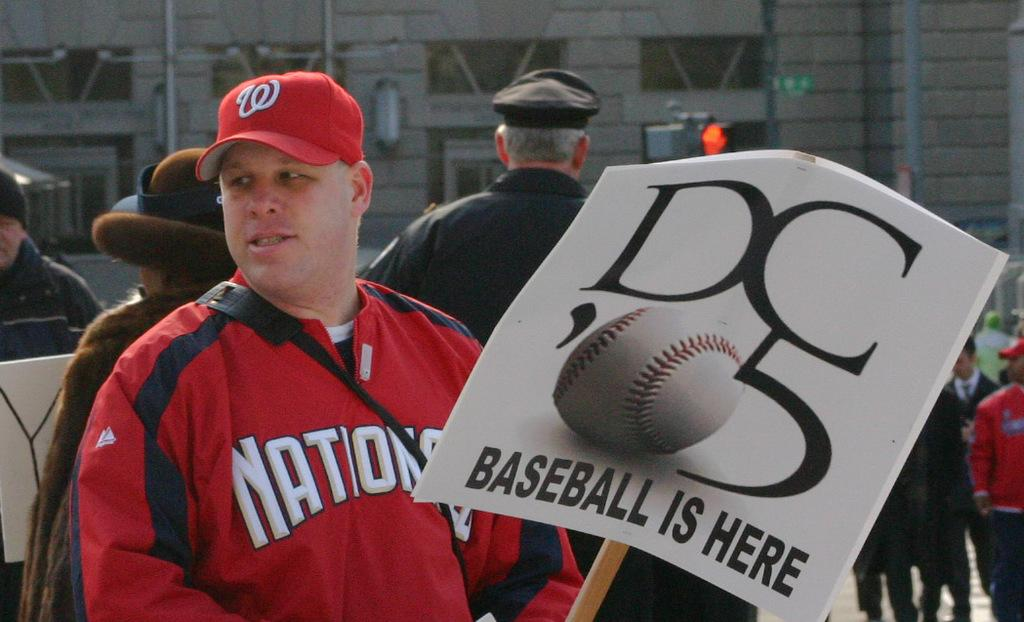<image>
Summarize the visual content of the image. Man holding a white sign which says DC on it. 